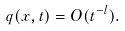<formula> <loc_0><loc_0><loc_500><loc_500>q ( x , t ) & = O ( t ^ { - l } ) .</formula> 